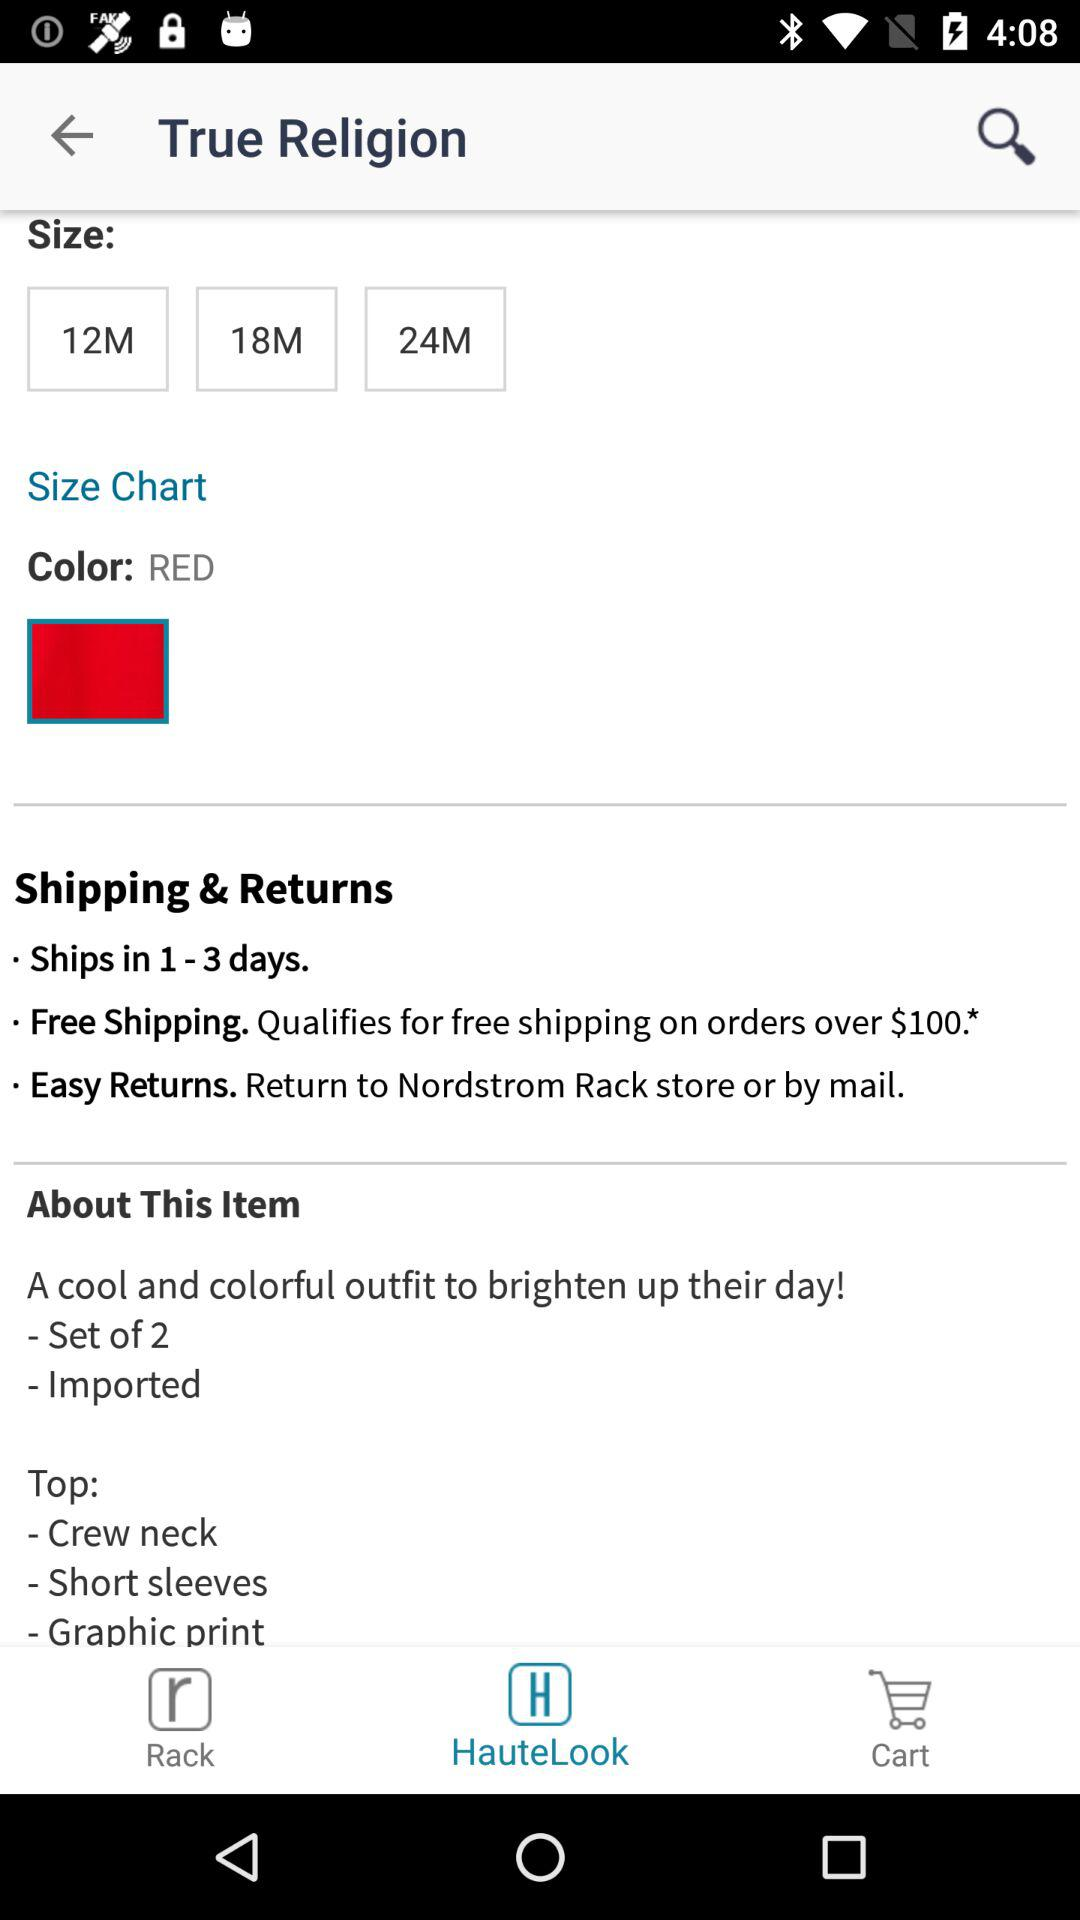How many days will it take to ship? It will take from 1 to 3 days to ship. 